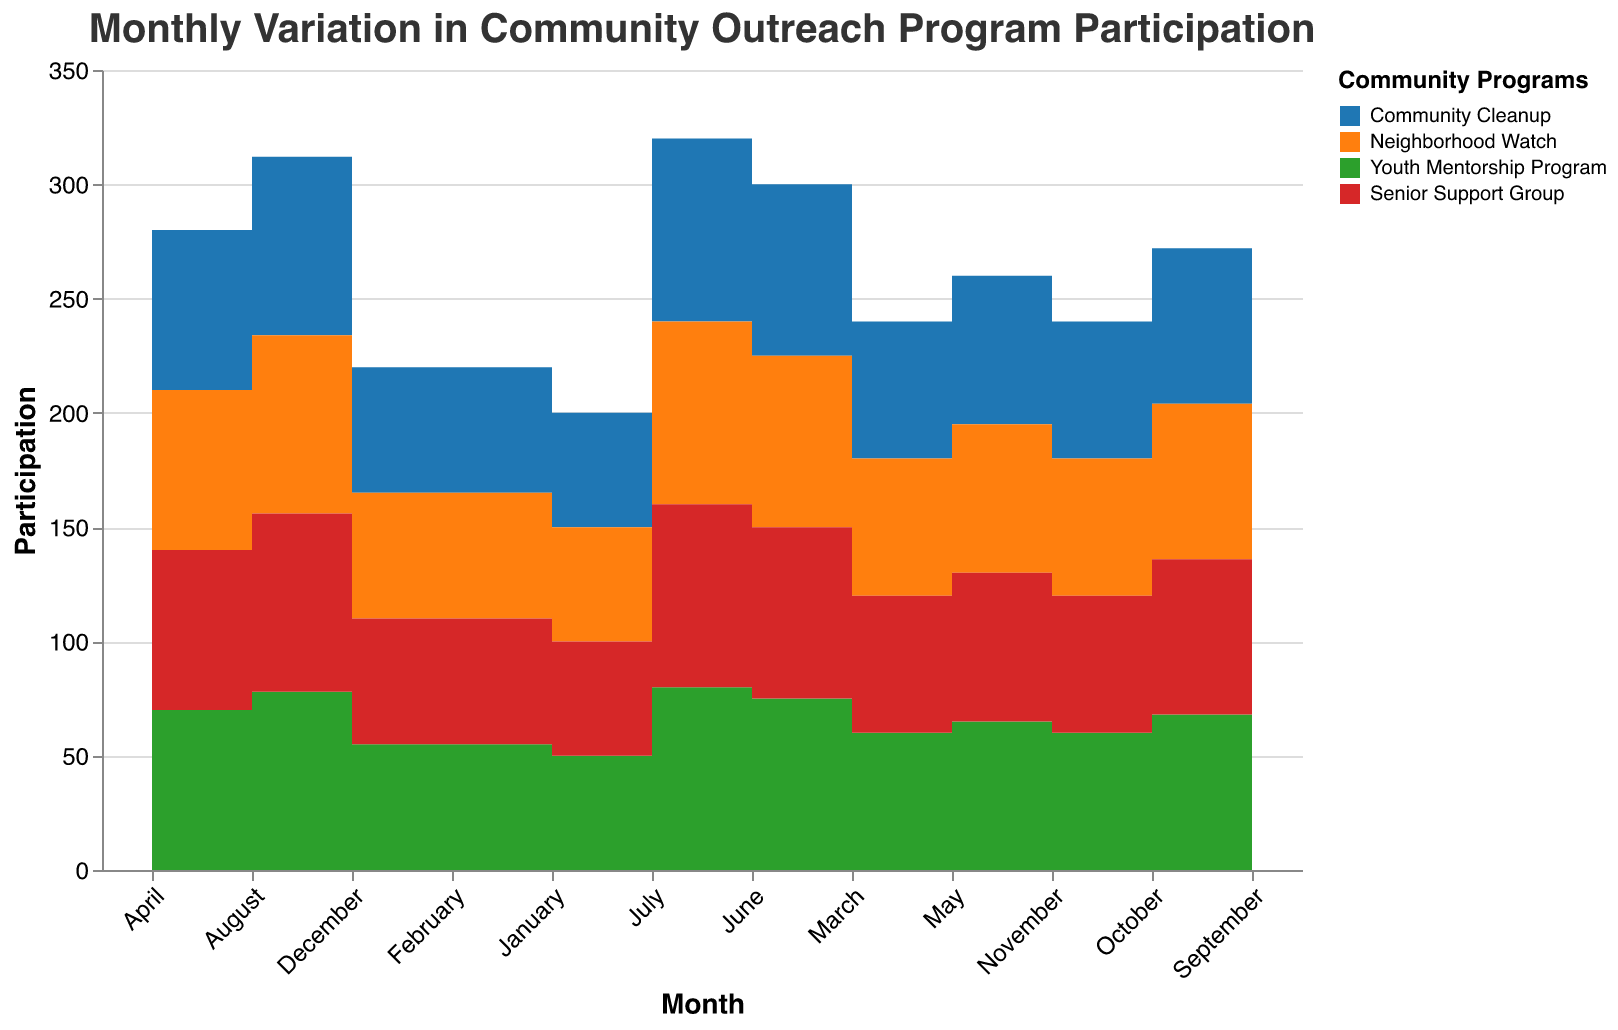What is the title of the figure? The title is displayed at the top of the figure in larger font size and states the subject of the chart.
Answer: Monthly Variation in Community Outreach Program Participation Which month had the highest participation in Community Cleanup? Look at the curve representing Community Cleanup for the highest peak, which occurs in July.
Answer: July How does the participation in the Youth Mentorship Program in August compare to July? Compare the heights of the areas representing Youth Mentorship Program for both months, noting that July is higher.
Answer: Lower in August What is the color used to represent the Neighborhood Watch program? Check the legend on the side of the chart which matches colors to program names.
Answer: Orange Which program had the lowest participation in March? Examine the comparative areas for each program in March; Senior Support Group is the smallest.
Answer: Senior Support Group What is the average participation in the Senior Support Group during the first quarter (January to March)? Add the participation values for January (15), February (18), and March (20), then divide by 3. (15+18+20)/3 = 17.67
Answer: 17.67 Which month saw the smallest difference in participation between the Community Cleanup and the Neighborhood Watch? Compute the difference, Community Cleanup - Neighborhood Watch, for each month and identify the smallest; it's March with 35 (60-25).
Answer: March During which months did the participation rates for the Community Cleanup program decline? Identify months where the step falls instead of rises; from July to August, August to September, and September to October.
Answer: August, September, October By how much did the participation in Community Cleanup decrease from July to December? Subtract the participation in December from that in July: 80 - 55 = 25
Answer: 25 In which month did the Youth Mentorship Program see the largest increase in participation compared to the previous month? Examine the step heights representing Youth Mentorship Program month-on-month; from March to April has the largest increase, 40 - 35 = 5.
Answer: April 